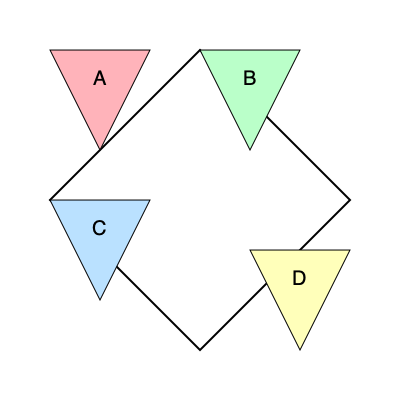As a teacher incorporating infographics into your lesson, you want to challenge your students' spatial intelligence. The image shows a target shape (outlined in black) and four colored puzzle pieces labeled A, B, C, and D. Which sequence of rotations and placements would correctly assemble these pieces to form the target shape? Let's approach this step-by-step:

1. Observe the target shape: It's a square rotated 45 degrees, forming a diamond shape.

2. Analyze each puzzle piece:
   A (pink): Top-left triangle
   B (green): Top-right triangle
   C (blue): Bottom-left triangle
   D (yellow): Bottom-right triangle

3. Determine the necessary rotations:
   A: Rotate 90° clockwise
   B: No rotation needed
   C: Rotate 180°
   D: Rotate 90° counterclockwise

4. Place the pieces:
   A: After rotation, place in the left corner of the diamond
   B: Place directly in the top corner of the diamond
   C: After rotation, place in the bottom corner of the diamond
   D: After rotation, place in the right corner of the diamond

5. Sequence the steps:
   1) Rotate and place A
   2) Place B
   3) Rotate and place C
   4) Rotate and place D

This sequence will correctly assemble the puzzle pieces to form the target diamond shape.
Answer: A (90° CW), B, C (180°), D (90° CCW) 